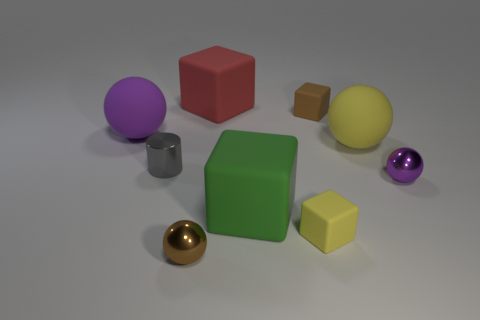What material is the brown object that is in front of the tiny cylinder?
Give a very brief answer. Metal. Is the number of yellow spheres that are to the left of the large green matte cube less than the number of purple matte blocks?
Offer a terse response. No. There is a brown object that is to the right of the big matte object that is behind the purple matte thing; what is its shape?
Keep it short and to the point. Cube. The small metal cylinder has what color?
Give a very brief answer. Gray. What number of other objects are the same size as the gray metallic cylinder?
Your response must be concise. 4. There is a small thing that is left of the red rubber thing and to the right of the gray thing; what material is it?
Your answer should be compact. Metal. There is a object left of the gray cylinder; is it the same size as the brown sphere?
Your answer should be very brief. No. How many metallic spheres are in front of the large green thing and on the right side of the small yellow object?
Offer a terse response. 0. There is a large matte block that is in front of the big ball that is on the left side of the tiny brown metal object; how many small brown things are on the right side of it?
Make the answer very short. 1. What is the shape of the red thing?
Provide a succinct answer. Cube. 